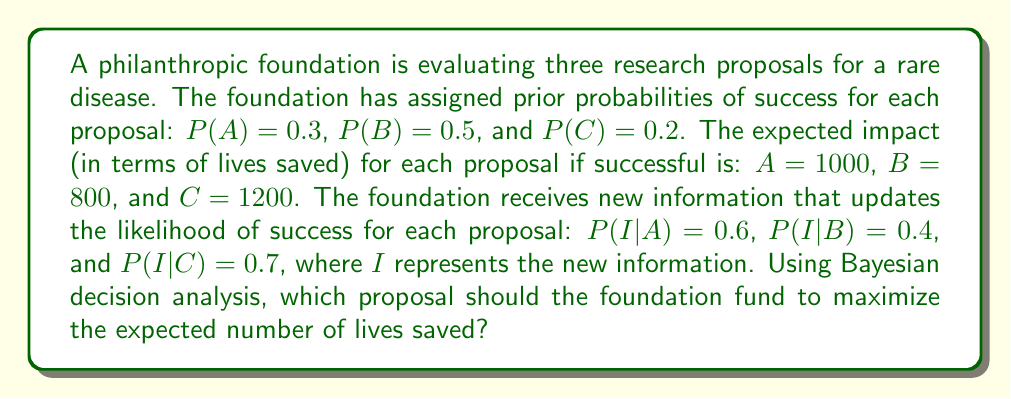Help me with this question. To solve this problem, we'll use Bayesian decision analysis. We'll follow these steps:

1. Calculate the posterior probabilities for each proposal using Bayes' theorem.
2. Calculate the expected number of lives saved for each proposal.
3. Choose the proposal with the highest expected value.

Step 1: Calculate posterior probabilities

Bayes' theorem: $P(X|I) = \frac{P(I|X) \cdot P(X)}{P(I)}$

First, calculate $P(I)$:
$$P(I) = P(I|A)P(A) + P(I|B)P(B) + P(I|C)P(C)$$
$$P(I) = (0.6 \cdot 0.3) + (0.4 \cdot 0.5) + (0.7 \cdot 0.2) = 0.18 + 0.20 + 0.14 = 0.52$$

Now, calculate posterior probabilities:

For proposal A:
$$P(A|I) = \frac{P(I|A) \cdot P(A)}{P(I)} = \frac{0.6 \cdot 0.3}{0.52} \approx 0.3462$$

For proposal B:
$$P(B|I) = \frac{P(I|B) \cdot P(B)}{P(I)} = \frac{0.4 \cdot 0.5}{0.52} \approx 0.3846$$

For proposal C:
$$P(C|I) = \frac{P(I|C) \cdot P(C)}{P(I)} = \frac{0.7 \cdot 0.2}{0.52} \approx 0.2692$$

Step 2: Calculate expected number of lives saved

For each proposal, multiply the posterior probability by the expected impact:

Proposal A: $0.3462 \cdot 1000 = 346.2$
Proposal B: $0.3846 \cdot 800 = 307.68$
Proposal C: $0.2692 \cdot 1200 = 323.04$

Step 3: Choose the proposal with the highest expected value

Proposal A has the highest expected number of lives saved at 346.2.
Answer: The foundation should fund Proposal A, which has the highest expected number of lives saved at 346.2. 